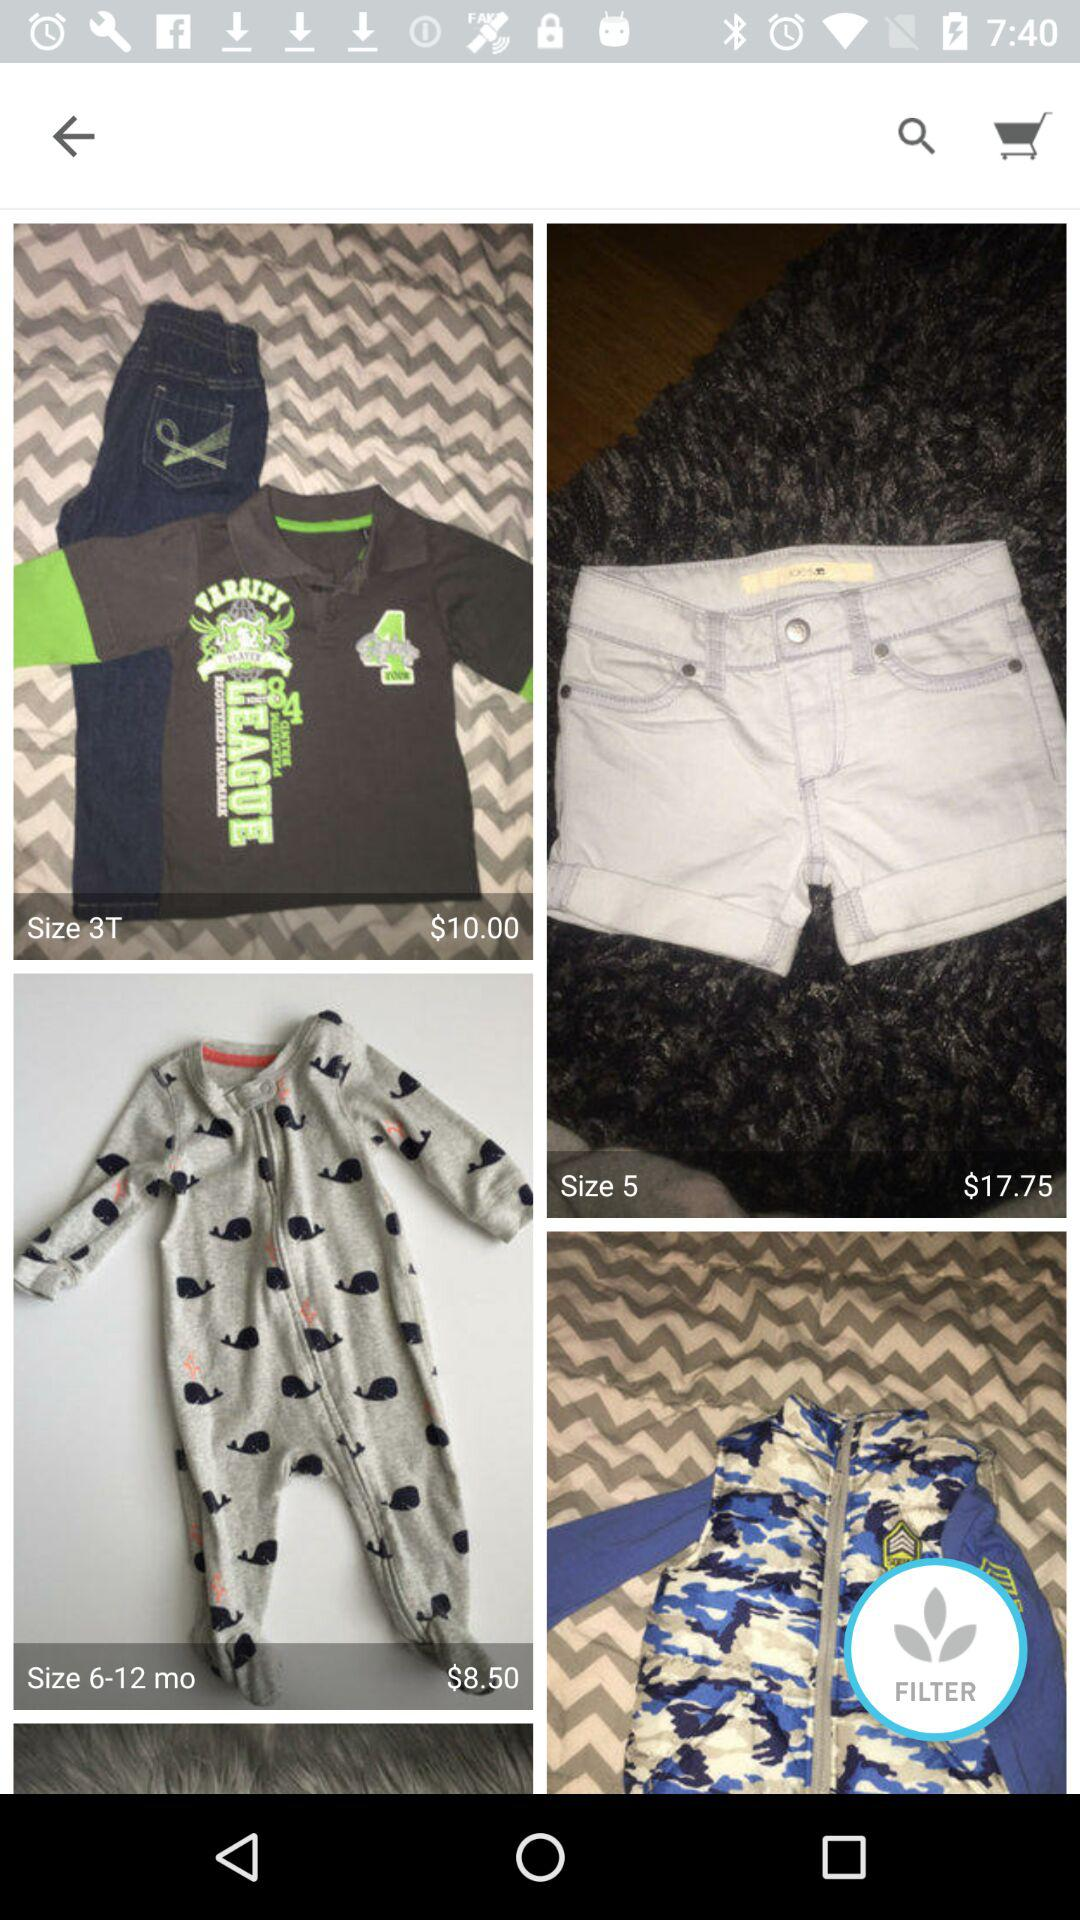What are the sizes of clothes? The sizes are 3T, 5, and 6-12 months. 